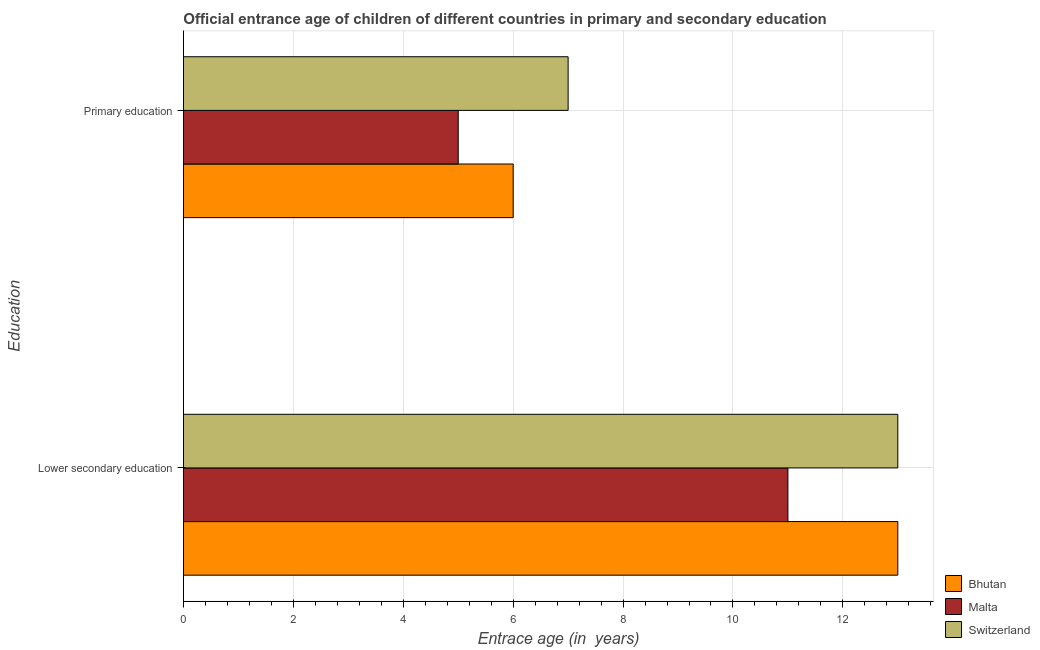How many different coloured bars are there?
Ensure brevity in your answer.  3. How many groups of bars are there?
Provide a succinct answer. 2. What is the label of the 2nd group of bars from the top?
Your answer should be very brief. Lower secondary education. What is the entrance age of children in lower secondary education in Bhutan?
Ensure brevity in your answer.  13. Across all countries, what is the maximum entrance age of chiildren in primary education?
Provide a short and direct response. 7. Across all countries, what is the minimum entrance age of children in lower secondary education?
Your response must be concise. 11. In which country was the entrance age of children in lower secondary education maximum?
Provide a succinct answer. Bhutan. In which country was the entrance age of children in lower secondary education minimum?
Give a very brief answer. Malta. What is the total entrance age of children in lower secondary education in the graph?
Keep it short and to the point. 37. What is the difference between the entrance age of children in lower secondary education in Malta and that in Bhutan?
Ensure brevity in your answer.  -2. What is the difference between the entrance age of chiildren in primary education in Bhutan and the entrance age of children in lower secondary education in Switzerland?
Your answer should be compact. -7. What is the average entrance age of chiildren in primary education per country?
Provide a short and direct response. 6. What is the difference between the entrance age of chiildren in primary education and entrance age of children in lower secondary education in Switzerland?
Offer a very short reply. -6. What is the ratio of the entrance age of chiildren in primary education in Bhutan to that in Switzerland?
Make the answer very short. 0.86. Is the entrance age of children in lower secondary education in Bhutan less than that in Switzerland?
Give a very brief answer. No. What does the 3rd bar from the top in Lower secondary education represents?
Your response must be concise. Bhutan. What does the 3rd bar from the bottom in Primary education represents?
Ensure brevity in your answer.  Switzerland. Are all the bars in the graph horizontal?
Keep it short and to the point. Yes. What is the difference between two consecutive major ticks on the X-axis?
Provide a short and direct response. 2. Are the values on the major ticks of X-axis written in scientific E-notation?
Provide a short and direct response. No. Does the graph contain grids?
Keep it short and to the point. Yes. How are the legend labels stacked?
Your response must be concise. Vertical. What is the title of the graph?
Offer a very short reply. Official entrance age of children of different countries in primary and secondary education. Does "Namibia" appear as one of the legend labels in the graph?
Your answer should be compact. No. What is the label or title of the X-axis?
Your answer should be compact. Entrace age (in  years). What is the label or title of the Y-axis?
Offer a terse response. Education. What is the Entrace age (in  years) of Bhutan in Lower secondary education?
Make the answer very short. 13. What is the Entrace age (in  years) of Malta in Lower secondary education?
Provide a succinct answer. 11. What is the Entrace age (in  years) in Malta in Primary education?
Keep it short and to the point. 5. What is the Entrace age (in  years) of Switzerland in Primary education?
Offer a very short reply. 7. Across all Education, what is the minimum Entrace age (in  years) of Malta?
Offer a terse response. 5. What is the total Entrace age (in  years) of Switzerland in the graph?
Keep it short and to the point. 20. What is the difference between the Entrace age (in  years) of Bhutan in Lower secondary education and that in Primary education?
Provide a succinct answer. 7. What is the difference between the Entrace age (in  years) of Switzerland in Lower secondary education and that in Primary education?
Your response must be concise. 6. What is the difference between the Entrace age (in  years) of Bhutan in Lower secondary education and the Entrace age (in  years) of Malta in Primary education?
Offer a very short reply. 8. What is the average Entrace age (in  years) in Switzerland per Education?
Provide a succinct answer. 10. What is the difference between the Entrace age (in  years) of Bhutan and Entrace age (in  years) of Malta in Lower secondary education?
Ensure brevity in your answer.  2. What is the difference between the Entrace age (in  years) in Bhutan and Entrace age (in  years) in Switzerland in Lower secondary education?
Your answer should be very brief. 0. What is the difference between the Entrace age (in  years) in Malta and Entrace age (in  years) in Switzerland in Lower secondary education?
Ensure brevity in your answer.  -2. What is the difference between the Entrace age (in  years) in Bhutan and Entrace age (in  years) in Malta in Primary education?
Give a very brief answer. 1. What is the difference between the Entrace age (in  years) of Bhutan and Entrace age (in  years) of Switzerland in Primary education?
Provide a succinct answer. -1. What is the difference between the Entrace age (in  years) of Malta and Entrace age (in  years) of Switzerland in Primary education?
Give a very brief answer. -2. What is the ratio of the Entrace age (in  years) in Bhutan in Lower secondary education to that in Primary education?
Offer a very short reply. 2.17. What is the ratio of the Entrace age (in  years) of Switzerland in Lower secondary education to that in Primary education?
Ensure brevity in your answer.  1.86. What is the difference between the highest and the second highest Entrace age (in  years) in Bhutan?
Offer a terse response. 7. What is the difference between the highest and the second highest Entrace age (in  years) in Malta?
Keep it short and to the point. 6. What is the difference between the highest and the second highest Entrace age (in  years) in Switzerland?
Ensure brevity in your answer.  6. What is the difference between the highest and the lowest Entrace age (in  years) of Switzerland?
Provide a short and direct response. 6. 